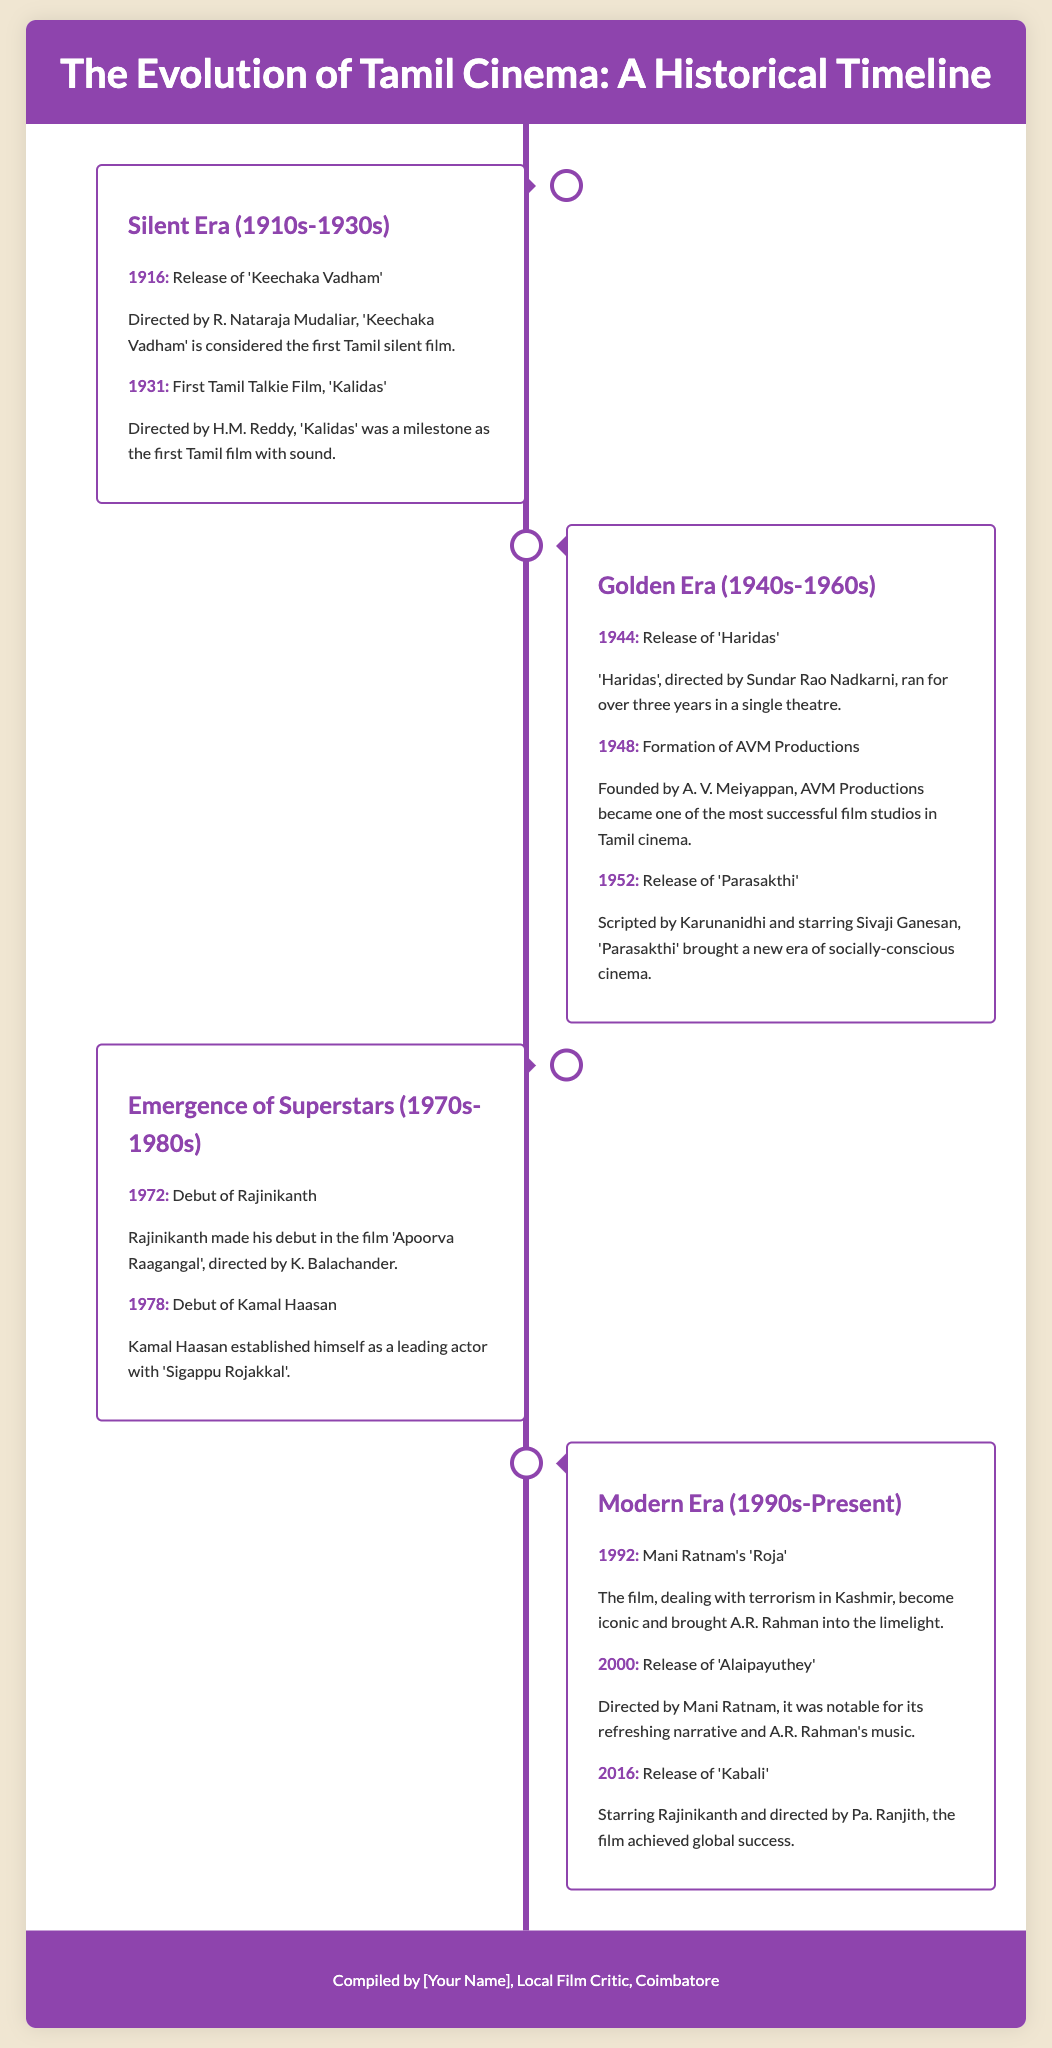What is considered the first Tamil silent film? The document states 'Keechaka Vadham' is considered the first Tamil silent film, released in 1916.
Answer: Keechaka Vadham In what year was the first Tamil Talkie film released? According to the timeline, the first Tamil talkie film, 'Kalidas', was released in 1931.
Answer: 1931 Who directed the film 'Parasakthi'? The document mentions that 'Parasakthi' was scripted by Karunanidhi and starred Sivaji Ganesan, highlighting that Karunanidhi was instrumental in its creation.
Answer: Karunanidhi What significant film studio was founded in 1948? The timeline indicates that AVM Productions, one of the most successful film studios, was founded in 1948.
Answer: AVM Productions Which actor made his debut in 1972? According to the timeline, Rajinikanth made his debut in the film 'Apoorva Raagangal' in 1972.
Answer: Rajinikanth What film became iconic in 1992 and helped bring A.R. Rahman into the limelight? The document states that Mani Ratnam's 'Roja' became iconic in 1992 and significantly contributed to A.R. Rahman's recognition.
Answer: Roja Which film, starring Rajinikanth, was released in 2016? The timeline highlights that 'Kabali', starring Rajinikanth, was released in 2016.
Answer: Kabali What is the name of the film that established Kamal Haasan as a leading actor? According to the timeline, 'Sigappu Rojakkal' established Kamal Haasan as a leading actor.
Answer: Sigappu Rojakkal What era does the document consider as the period of 'Emergence of Superstars'? The document categorizes the time frame from the 1970s to the 1980s as the 'Emergence of Superstars' era.
Answer: 1970s-1980s 